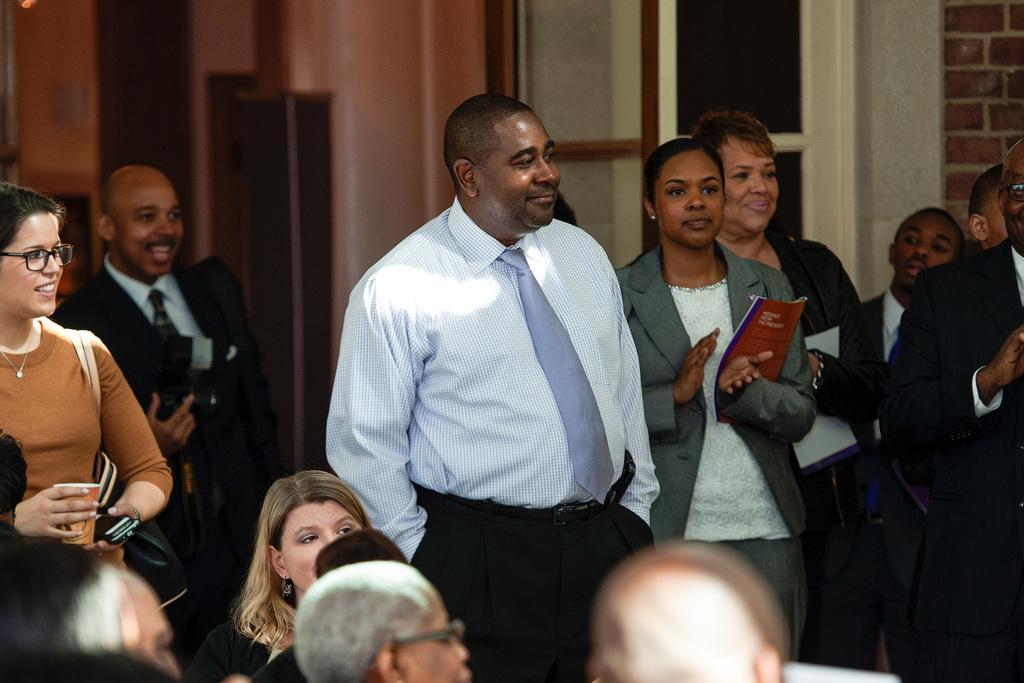In one or two sentences, can you explain what this image depicts? This picture describes about group of people, few are sitting and few are standing, on the left side of the image we can see a woman, she wore spectacles, she is holding a glass and mobiles. 